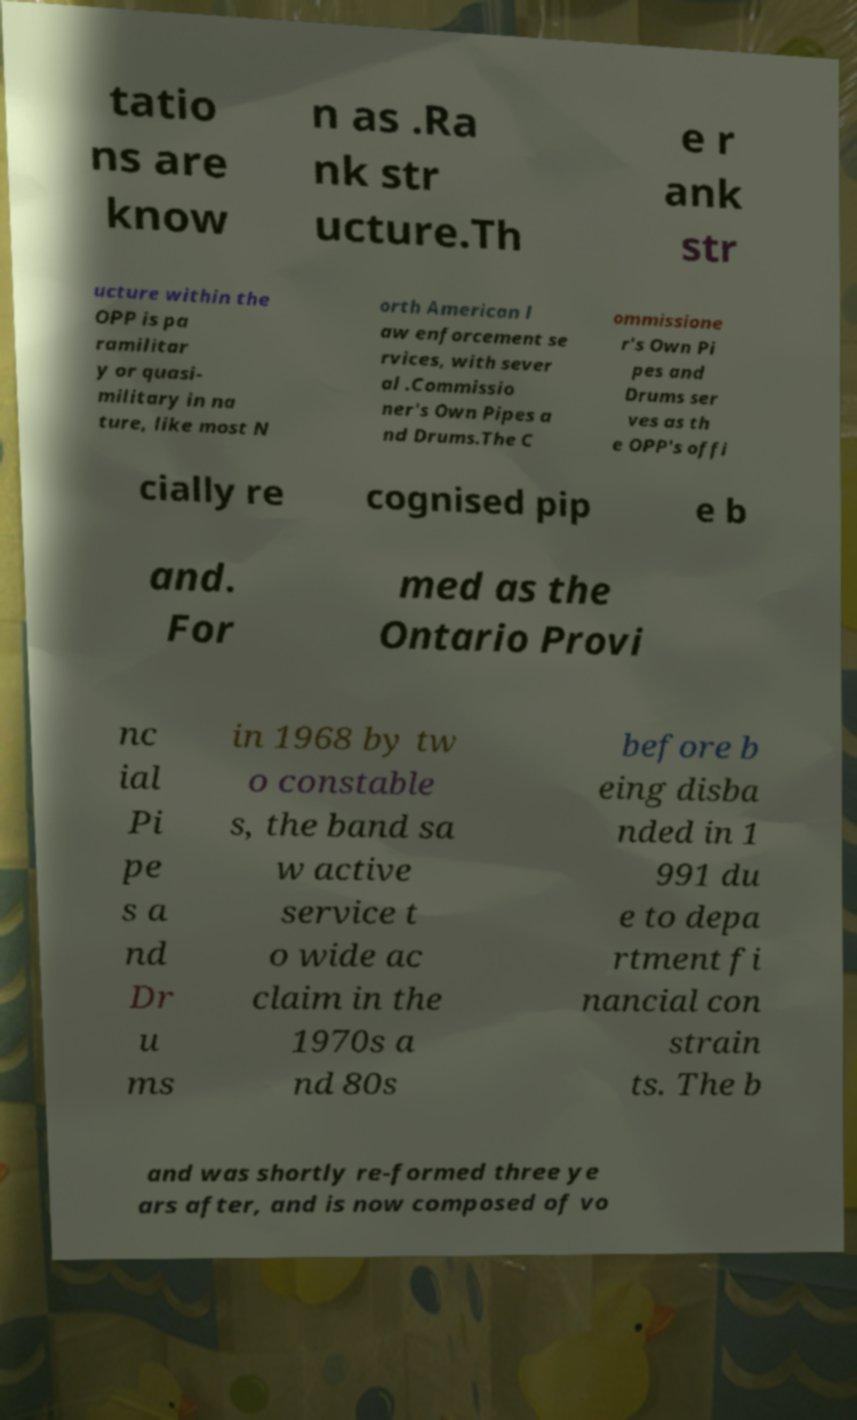I need the written content from this picture converted into text. Can you do that? tatio ns are know n as .Ra nk str ucture.Th e r ank str ucture within the OPP is pa ramilitar y or quasi- military in na ture, like most N orth American l aw enforcement se rvices, with sever al .Commissio ner's Own Pipes a nd Drums.The C ommissione r's Own Pi pes and Drums ser ves as th e OPP's offi cially re cognised pip e b and. For med as the Ontario Provi nc ial Pi pe s a nd Dr u ms in 1968 by tw o constable s, the band sa w active service t o wide ac claim in the 1970s a nd 80s before b eing disba nded in 1 991 du e to depa rtment fi nancial con strain ts. The b and was shortly re-formed three ye ars after, and is now composed of vo 